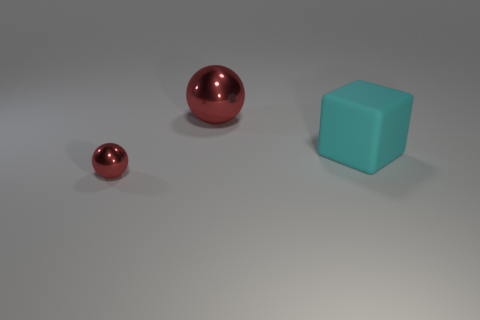Is the color of the sphere that is to the right of the tiny metallic object the same as the tiny metallic object that is left of the large red thing?
Offer a terse response. Yes. Is there a purple metal ball of the same size as the matte object?
Keep it short and to the point. No. Are there fewer big cyan rubber things to the right of the rubber object than red shiny objects?
Give a very brief answer. Yes. Are there fewer large cyan cubes behind the large shiny object than spheres that are behind the big cyan rubber cube?
Your answer should be very brief. Yes. How many balls are big cyan rubber things or red objects?
Make the answer very short. 2. Are the red object that is in front of the big cyan thing and the big thing in front of the big metallic ball made of the same material?
Provide a short and direct response. No. There is a red thing that is the same size as the matte block; what shape is it?
Give a very brief answer. Sphere. What number of other objects are there of the same color as the small object?
Ensure brevity in your answer.  1. What number of red things are either cubes or shiny things?
Offer a very short reply. 2. Does the thing behind the matte object have the same shape as the big thing on the right side of the large metallic sphere?
Your answer should be very brief. No. 